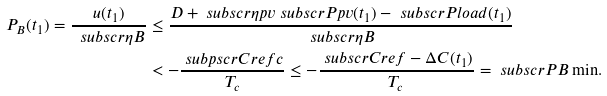<formula> <loc_0><loc_0><loc_500><loc_500>P _ { B } ( t _ { 1 } ) = \frac { u ( t _ { 1 } ) } { \ s u b s c r { \eta } { B } } & \leq \frac { D + \ s u b s c r { \eta } { p v } \ s u b s c r { P } { p v } ( t _ { 1 } ) - \ s u b s c r { P } { l o a d } ( t _ { 1 } ) } { \ s u b s c r { \eta } { B } } \\ & < - \frac { \ s u b p s c r { C } { r e f } { c } } { T _ { c } } \leq - \frac { \ s u b s c r { C } { r e f } - \Delta C ( t _ { 1 } ) } { T _ { c } } = \ s u b s c r { P } { B \min } .</formula> 